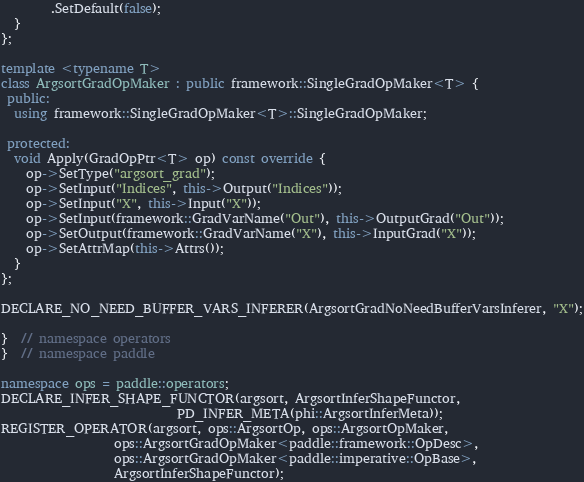Convert code to text. <code><loc_0><loc_0><loc_500><loc_500><_C++_>        .SetDefault(false);
  }
};

template <typename T>
class ArgsortGradOpMaker : public framework::SingleGradOpMaker<T> {
 public:
  using framework::SingleGradOpMaker<T>::SingleGradOpMaker;

 protected:
  void Apply(GradOpPtr<T> op) const override {
    op->SetType("argsort_grad");
    op->SetInput("Indices", this->Output("Indices"));
    op->SetInput("X", this->Input("X"));
    op->SetInput(framework::GradVarName("Out"), this->OutputGrad("Out"));
    op->SetOutput(framework::GradVarName("X"), this->InputGrad("X"));
    op->SetAttrMap(this->Attrs());
  }
};

DECLARE_NO_NEED_BUFFER_VARS_INFERER(ArgsortGradNoNeedBufferVarsInferer, "X");

}  // namespace operators
}  // namespace paddle

namespace ops = paddle::operators;
DECLARE_INFER_SHAPE_FUNCTOR(argsort, ArgsortInferShapeFunctor,
                            PD_INFER_META(phi::ArgsortInferMeta));
REGISTER_OPERATOR(argsort, ops::ArgsortOp, ops::ArgsortOpMaker,
                  ops::ArgsortGradOpMaker<paddle::framework::OpDesc>,
                  ops::ArgsortGradOpMaker<paddle::imperative::OpBase>,
                  ArgsortInferShapeFunctor);</code> 